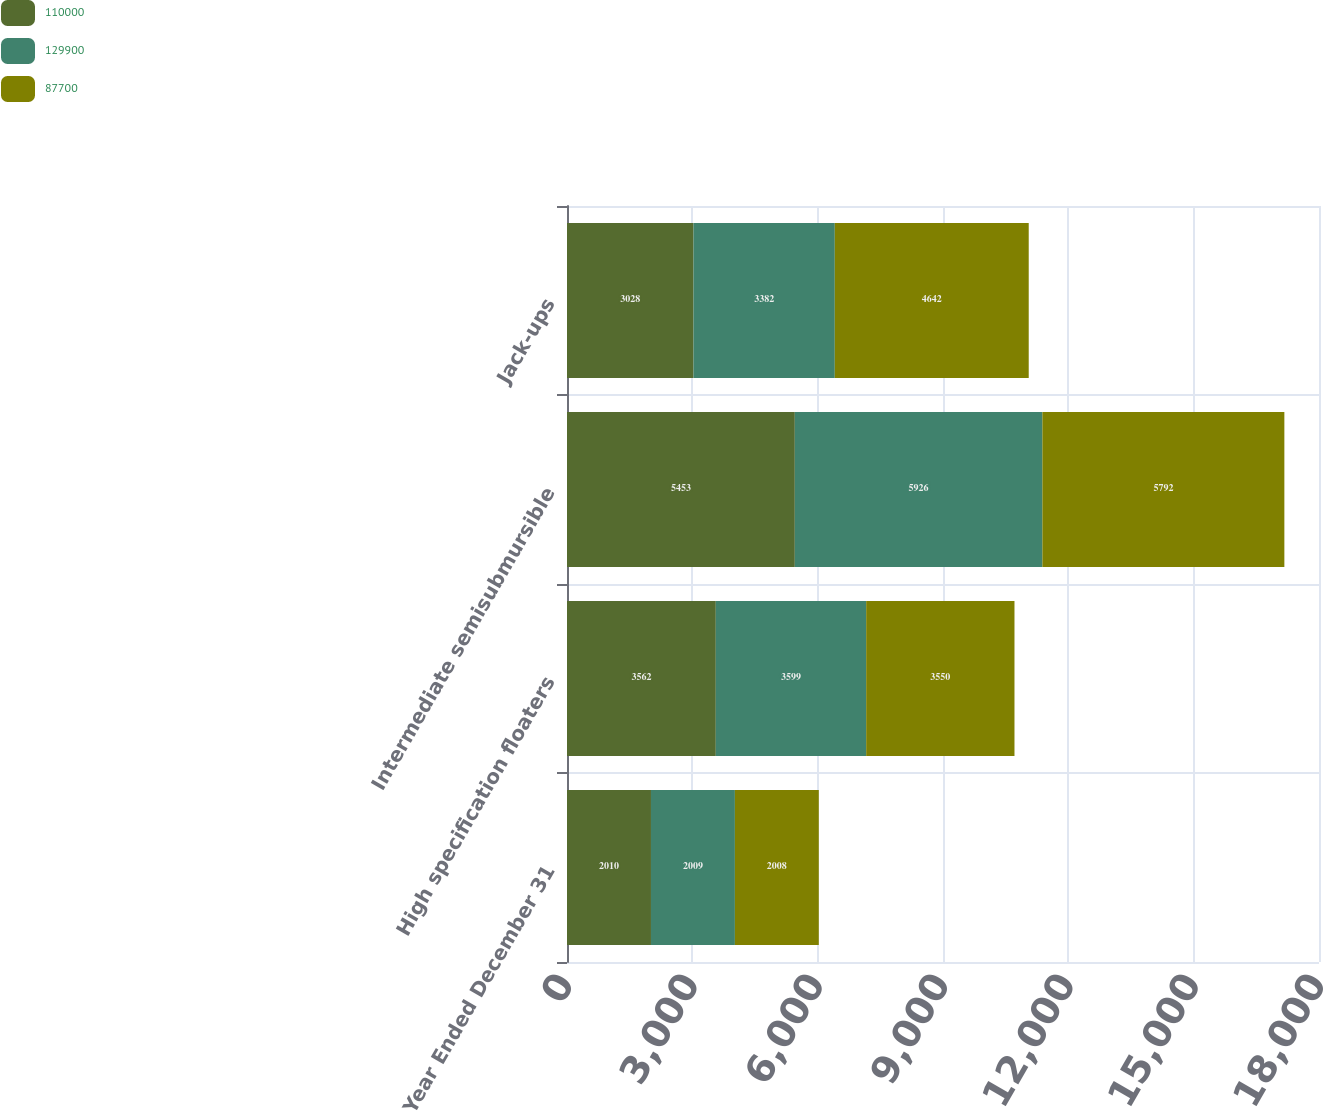Convert chart to OTSL. <chart><loc_0><loc_0><loc_500><loc_500><stacked_bar_chart><ecel><fcel>Year Ended December 31<fcel>High specification floaters<fcel>Intermediate semisubmursible<fcel>Jack-ups<nl><fcel>110000<fcel>2010<fcel>3562<fcel>5453<fcel>3028<nl><fcel>129900<fcel>2009<fcel>3599<fcel>5926<fcel>3382<nl><fcel>87700<fcel>2008<fcel>3550<fcel>5792<fcel>4642<nl></chart> 